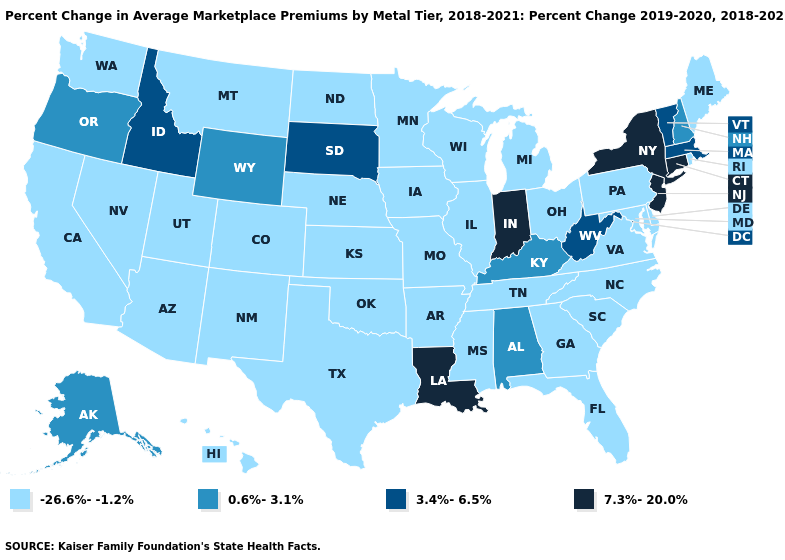Name the states that have a value in the range 7.3%-20.0%?
Keep it brief. Connecticut, Indiana, Louisiana, New Jersey, New York. Name the states that have a value in the range 7.3%-20.0%?
Quick response, please. Connecticut, Indiana, Louisiana, New Jersey, New York. What is the value of North Carolina?
Write a very short answer. -26.6%--1.2%. What is the highest value in the USA?
Concise answer only. 7.3%-20.0%. Name the states that have a value in the range 7.3%-20.0%?
Write a very short answer. Connecticut, Indiana, Louisiana, New Jersey, New York. Name the states that have a value in the range 3.4%-6.5%?
Quick response, please. Idaho, Massachusetts, South Dakota, Vermont, West Virginia. What is the value of North Dakota?
Be succinct. -26.6%--1.2%. Does the first symbol in the legend represent the smallest category?
Concise answer only. Yes. What is the lowest value in the USA?
Write a very short answer. -26.6%--1.2%. What is the highest value in the USA?
Be succinct. 7.3%-20.0%. Name the states that have a value in the range 7.3%-20.0%?
Give a very brief answer. Connecticut, Indiana, Louisiana, New Jersey, New York. What is the value of Delaware?
Write a very short answer. -26.6%--1.2%. What is the value of Minnesota?
Keep it brief. -26.6%--1.2%. Is the legend a continuous bar?
Give a very brief answer. No. Among the states that border Oklahoma , which have the lowest value?
Concise answer only. Arkansas, Colorado, Kansas, Missouri, New Mexico, Texas. 